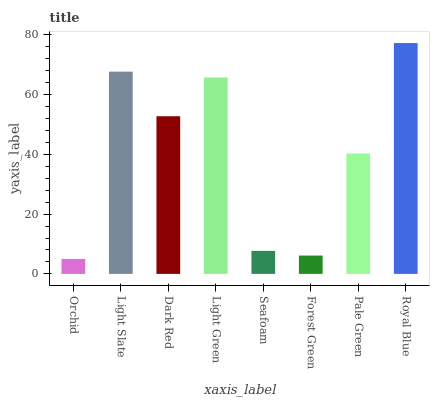Is Light Slate the minimum?
Answer yes or no. No. Is Light Slate the maximum?
Answer yes or no. No. Is Light Slate greater than Orchid?
Answer yes or no. Yes. Is Orchid less than Light Slate?
Answer yes or no. Yes. Is Orchid greater than Light Slate?
Answer yes or no. No. Is Light Slate less than Orchid?
Answer yes or no. No. Is Dark Red the high median?
Answer yes or no. Yes. Is Pale Green the low median?
Answer yes or no. Yes. Is Royal Blue the high median?
Answer yes or no. No. Is Royal Blue the low median?
Answer yes or no. No. 